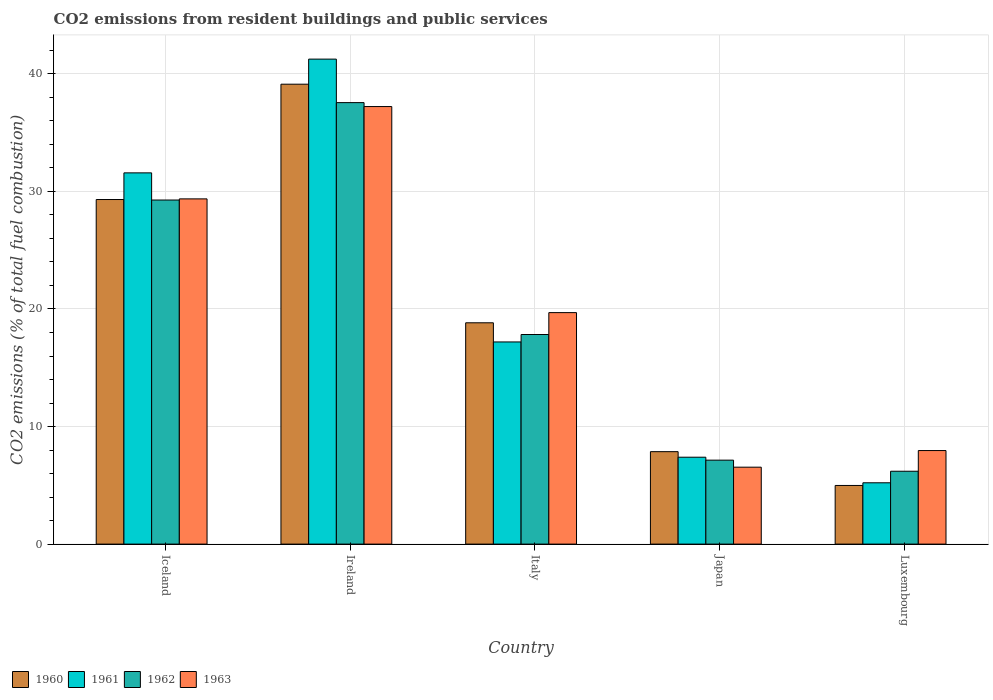How many different coloured bars are there?
Offer a terse response. 4. Are the number of bars per tick equal to the number of legend labels?
Ensure brevity in your answer.  Yes. Are the number of bars on each tick of the X-axis equal?
Offer a very short reply. Yes. How many bars are there on the 2nd tick from the right?
Provide a short and direct response. 4. What is the label of the 5th group of bars from the left?
Give a very brief answer. Luxembourg. In how many cases, is the number of bars for a given country not equal to the number of legend labels?
Offer a very short reply. 0. What is the total CO2 emitted in 1960 in Japan?
Ensure brevity in your answer.  7.86. Across all countries, what is the maximum total CO2 emitted in 1963?
Your response must be concise. 37.22. Across all countries, what is the minimum total CO2 emitted in 1962?
Offer a terse response. 6.2. In which country was the total CO2 emitted in 1962 maximum?
Offer a terse response. Ireland. In which country was the total CO2 emitted in 1962 minimum?
Ensure brevity in your answer.  Luxembourg. What is the total total CO2 emitted in 1961 in the graph?
Your answer should be very brief. 102.63. What is the difference between the total CO2 emitted in 1960 in Japan and that in Luxembourg?
Provide a succinct answer. 2.87. What is the difference between the total CO2 emitted in 1963 in Iceland and the total CO2 emitted in 1961 in Italy?
Keep it short and to the point. 12.17. What is the average total CO2 emitted in 1961 per country?
Keep it short and to the point. 20.53. What is the difference between the total CO2 emitted of/in 1960 and total CO2 emitted of/in 1961 in Luxembourg?
Your answer should be very brief. -0.23. What is the ratio of the total CO2 emitted in 1963 in Iceland to that in Italy?
Keep it short and to the point. 1.49. Is the total CO2 emitted in 1960 in Japan less than that in Luxembourg?
Provide a short and direct response. No. What is the difference between the highest and the second highest total CO2 emitted in 1962?
Ensure brevity in your answer.  -11.44. What is the difference between the highest and the lowest total CO2 emitted in 1961?
Your answer should be compact. 36.04. In how many countries, is the total CO2 emitted in 1963 greater than the average total CO2 emitted in 1963 taken over all countries?
Provide a succinct answer. 2. Is it the case that in every country, the sum of the total CO2 emitted in 1961 and total CO2 emitted in 1963 is greater than the sum of total CO2 emitted in 1962 and total CO2 emitted in 1960?
Keep it short and to the point. No. Are all the bars in the graph horizontal?
Provide a succinct answer. No. Are the values on the major ticks of Y-axis written in scientific E-notation?
Offer a terse response. No. Does the graph contain any zero values?
Your answer should be compact. No. Does the graph contain grids?
Give a very brief answer. Yes. How many legend labels are there?
Your response must be concise. 4. What is the title of the graph?
Provide a short and direct response. CO2 emissions from resident buildings and public services. Does "1971" appear as one of the legend labels in the graph?
Give a very brief answer. No. What is the label or title of the Y-axis?
Provide a succinct answer. CO2 emissions (% of total fuel combustion). What is the CO2 emissions (% of total fuel combustion) in 1960 in Iceland?
Offer a terse response. 29.31. What is the CO2 emissions (% of total fuel combustion) of 1961 in Iceland?
Offer a terse response. 31.58. What is the CO2 emissions (% of total fuel combustion) in 1962 in Iceland?
Offer a very short reply. 29.27. What is the CO2 emissions (% of total fuel combustion) in 1963 in Iceland?
Give a very brief answer. 29.37. What is the CO2 emissions (% of total fuel combustion) of 1960 in Ireland?
Offer a very short reply. 39.12. What is the CO2 emissions (% of total fuel combustion) of 1961 in Ireland?
Make the answer very short. 41.25. What is the CO2 emissions (% of total fuel combustion) of 1962 in Ireland?
Offer a terse response. 37.55. What is the CO2 emissions (% of total fuel combustion) in 1963 in Ireland?
Keep it short and to the point. 37.22. What is the CO2 emissions (% of total fuel combustion) of 1960 in Italy?
Offer a very short reply. 18.83. What is the CO2 emissions (% of total fuel combustion) of 1961 in Italy?
Your response must be concise. 17.2. What is the CO2 emissions (% of total fuel combustion) in 1962 in Italy?
Your response must be concise. 17.83. What is the CO2 emissions (% of total fuel combustion) of 1963 in Italy?
Ensure brevity in your answer.  19.69. What is the CO2 emissions (% of total fuel combustion) in 1960 in Japan?
Give a very brief answer. 7.86. What is the CO2 emissions (% of total fuel combustion) of 1961 in Japan?
Provide a succinct answer. 7.39. What is the CO2 emissions (% of total fuel combustion) of 1962 in Japan?
Your answer should be compact. 7.14. What is the CO2 emissions (% of total fuel combustion) of 1963 in Japan?
Provide a succinct answer. 6.54. What is the CO2 emissions (% of total fuel combustion) in 1960 in Luxembourg?
Provide a short and direct response. 4.99. What is the CO2 emissions (% of total fuel combustion) of 1961 in Luxembourg?
Your answer should be very brief. 5.21. What is the CO2 emissions (% of total fuel combustion) in 1962 in Luxembourg?
Your answer should be very brief. 6.2. What is the CO2 emissions (% of total fuel combustion) of 1963 in Luxembourg?
Keep it short and to the point. 7.96. Across all countries, what is the maximum CO2 emissions (% of total fuel combustion) of 1960?
Provide a succinct answer. 39.12. Across all countries, what is the maximum CO2 emissions (% of total fuel combustion) of 1961?
Give a very brief answer. 41.25. Across all countries, what is the maximum CO2 emissions (% of total fuel combustion) in 1962?
Your answer should be compact. 37.55. Across all countries, what is the maximum CO2 emissions (% of total fuel combustion) of 1963?
Give a very brief answer. 37.22. Across all countries, what is the minimum CO2 emissions (% of total fuel combustion) in 1960?
Make the answer very short. 4.99. Across all countries, what is the minimum CO2 emissions (% of total fuel combustion) of 1961?
Offer a terse response. 5.21. Across all countries, what is the minimum CO2 emissions (% of total fuel combustion) of 1962?
Make the answer very short. 6.2. Across all countries, what is the minimum CO2 emissions (% of total fuel combustion) in 1963?
Offer a terse response. 6.54. What is the total CO2 emissions (% of total fuel combustion) of 1960 in the graph?
Your response must be concise. 100.11. What is the total CO2 emissions (% of total fuel combustion) in 1961 in the graph?
Keep it short and to the point. 102.63. What is the total CO2 emissions (% of total fuel combustion) of 1962 in the graph?
Give a very brief answer. 97.99. What is the total CO2 emissions (% of total fuel combustion) of 1963 in the graph?
Provide a succinct answer. 100.78. What is the difference between the CO2 emissions (% of total fuel combustion) of 1960 in Iceland and that in Ireland?
Your response must be concise. -9.81. What is the difference between the CO2 emissions (% of total fuel combustion) of 1961 in Iceland and that in Ireland?
Offer a very short reply. -9.67. What is the difference between the CO2 emissions (% of total fuel combustion) in 1962 in Iceland and that in Ireland?
Offer a terse response. -8.29. What is the difference between the CO2 emissions (% of total fuel combustion) of 1963 in Iceland and that in Ireland?
Your answer should be compact. -7.85. What is the difference between the CO2 emissions (% of total fuel combustion) in 1960 in Iceland and that in Italy?
Your answer should be compact. 10.48. What is the difference between the CO2 emissions (% of total fuel combustion) of 1961 in Iceland and that in Italy?
Ensure brevity in your answer.  14.38. What is the difference between the CO2 emissions (% of total fuel combustion) in 1962 in Iceland and that in Italy?
Offer a terse response. 11.44. What is the difference between the CO2 emissions (% of total fuel combustion) of 1963 in Iceland and that in Italy?
Your answer should be compact. 9.67. What is the difference between the CO2 emissions (% of total fuel combustion) in 1960 in Iceland and that in Japan?
Your answer should be compact. 21.45. What is the difference between the CO2 emissions (% of total fuel combustion) of 1961 in Iceland and that in Japan?
Provide a succinct answer. 24.19. What is the difference between the CO2 emissions (% of total fuel combustion) in 1962 in Iceland and that in Japan?
Offer a very short reply. 22.13. What is the difference between the CO2 emissions (% of total fuel combustion) in 1963 in Iceland and that in Japan?
Give a very brief answer. 22.82. What is the difference between the CO2 emissions (% of total fuel combustion) of 1960 in Iceland and that in Luxembourg?
Make the answer very short. 24.32. What is the difference between the CO2 emissions (% of total fuel combustion) of 1961 in Iceland and that in Luxembourg?
Your response must be concise. 26.36. What is the difference between the CO2 emissions (% of total fuel combustion) of 1962 in Iceland and that in Luxembourg?
Your answer should be very brief. 23.07. What is the difference between the CO2 emissions (% of total fuel combustion) of 1963 in Iceland and that in Luxembourg?
Your answer should be compact. 21.41. What is the difference between the CO2 emissions (% of total fuel combustion) in 1960 in Ireland and that in Italy?
Provide a succinct answer. 20.29. What is the difference between the CO2 emissions (% of total fuel combustion) of 1961 in Ireland and that in Italy?
Your answer should be compact. 24.06. What is the difference between the CO2 emissions (% of total fuel combustion) of 1962 in Ireland and that in Italy?
Provide a short and direct response. 19.73. What is the difference between the CO2 emissions (% of total fuel combustion) of 1963 in Ireland and that in Italy?
Give a very brief answer. 17.53. What is the difference between the CO2 emissions (% of total fuel combustion) of 1960 in Ireland and that in Japan?
Provide a short and direct response. 31.26. What is the difference between the CO2 emissions (% of total fuel combustion) in 1961 in Ireland and that in Japan?
Provide a short and direct response. 33.86. What is the difference between the CO2 emissions (% of total fuel combustion) of 1962 in Ireland and that in Japan?
Offer a very short reply. 30.41. What is the difference between the CO2 emissions (% of total fuel combustion) of 1963 in Ireland and that in Japan?
Provide a succinct answer. 30.68. What is the difference between the CO2 emissions (% of total fuel combustion) of 1960 in Ireland and that in Luxembourg?
Make the answer very short. 34.13. What is the difference between the CO2 emissions (% of total fuel combustion) in 1961 in Ireland and that in Luxembourg?
Offer a terse response. 36.04. What is the difference between the CO2 emissions (% of total fuel combustion) of 1962 in Ireland and that in Luxembourg?
Make the answer very short. 31.36. What is the difference between the CO2 emissions (% of total fuel combustion) in 1963 in Ireland and that in Luxembourg?
Your response must be concise. 29.26. What is the difference between the CO2 emissions (% of total fuel combustion) in 1960 in Italy and that in Japan?
Offer a very short reply. 10.96. What is the difference between the CO2 emissions (% of total fuel combustion) in 1961 in Italy and that in Japan?
Give a very brief answer. 9.81. What is the difference between the CO2 emissions (% of total fuel combustion) of 1962 in Italy and that in Japan?
Give a very brief answer. 10.69. What is the difference between the CO2 emissions (% of total fuel combustion) in 1963 in Italy and that in Japan?
Ensure brevity in your answer.  13.15. What is the difference between the CO2 emissions (% of total fuel combustion) in 1960 in Italy and that in Luxembourg?
Keep it short and to the point. 13.84. What is the difference between the CO2 emissions (% of total fuel combustion) in 1961 in Italy and that in Luxembourg?
Make the answer very short. 11.98. What is the difference between the CO2 emissions (% of total fuel combustion) of 1962 in Italy and that in Luxembourg?
Offer a very short reply. 11.63. What is the difference between the CO2 emissions (% of total fuel combustion) of 1963 in Italy and that in Luxembourg?
Keep it short and to the point. 11.73. What is the difference between the CO2 emissions (% of total fuel combustion) in 1960 in Japan and that in Luxembourg?
Provide a succinct answer. 2.87. What is the difference between the CO2 emissions (% of total fuel combustion) of 1961 in Japan and that in Luxembourg?
Make the answer very short. 2.18. What is the difference between the CO2 emissions (% of total fuel combustion) in 1962 in Japan and that in Luxembourg?
Provide a succinct answer. 0.94. What is the difference between the CO2 emissions (% of total fuel combustion) in 1963 in Japan and that in Luxembourg?
Offer a terse response. -1.41. What is the difference between the CO2 emissions (% of total fuel combustion) in 1960 in Iceland and the CO2 emissions (% of total fuel combustion) in 1961 in Ireland?
Provide a short and direct response. -11.94. What is the difference between the CO2 emissions (% of total fuel combustion) of 1960 in Iceland and the CO2 emissions (% of total fuel combustion) of 1962 in Ireland?
Give a very brief answer. -8.24. What is the difference between the CO2 emissions (% of total fuel combustion) of 1960 in Iceland and the CO2 emissions (% of total fuel combustion) of 1963 in Ireland?
Give a very brief answer. -7.91. What is the difference between the CO2 emissions (% of total fuel combustion) of 1961 in Iceland and the CO2 emissions (% of total fuel combustion) of 1962 in Ireland?
Keep it short and to the point. -5.98. What is the difference between the CO2 emissions (% of total fuel combustion) in 1961 in Iceland and the CO2 emissions (% of total fuel combustion) in 1963 in Ireland?
Your response must be concise. -5.64. What is the difference between the CO2 emissions (% of total fuel combustion) of 1962 in Iceland and the CO2 emissions (% of total fuel combustion) of 1963 in Ireland?
Offer a very short reply. -7.95. What is the difference between the CO2 emissions (% of total fuel combustion) of 1960 in Iceland and the CO2 emissions (% of total fuel combustion) of 1961 in Italy?
Make the answer very short. 12.11. What is the difference between the CO2 emissions (% of total fuel combustion) in 1960 in Iceland and the CO2 emissions (% of total fuel combustion) in 1962 in Italy?
Make the answer very short. 11.48. What is the difference between the CO2 emissions (% of total fuel combustion) in 1960 in Iceland and the CO2 emissions (% of total fuel combustion) in 1963 in Italy?
Keep it short and to the point. 9.62. What is the difference between the CO2 emissions (% of total fuel combustion) in 1961 in Iceland and the CO2 emissions (% of total fuel combustion) in 1962 in Italy?
Provide a short and direct response. 13.75. What is the difference between the CO2 emissions (% of total fuel combustion) in 1961 in Iceland and the CO2 emissions (% of total fuel combustion) in 1963 in Italy?
Offer a terse response. 11.89. What is the difference between the CO2 emissions (% of total fuel combustion) in 1962 in Iceland and the CO2 emissions (% of total fuel combustion) in 1963 in Italy?
Make the answer very short. 9.58. What is the difference between the CO2 emissions (% of total fuel combustion) in 1960 in Iceland and the CO2 emissions (% of total fuel combustion) in 1961 in Japan?
Provide a succinct answer. 21.92. What is the difference between the CO2 emissions (% of total fuel combustion) in 1960 in Iceland and the CO2 emissions (% of total fuel combustion) in 1962 in Japan?
Your answer should be compact. 22.17. What is the difference between the CO2 emissions (% of total fuel combustion) in 1960 in Iceland and the CO2 emissions (% of total fuel combustion) in 1963 in Japan?
Give a very brief answer. 22.77. What is the difference between the CO2 emissions (% of total fuel combustion) in 1961 in Iceland and the CO2 emissions (% of total fuel combustion) in 1962 in Japan?
Offer a very short reply. 24.44. What is the difference between the CO2 emissions (% of total fuel combustion) in 1961 in Iceland and the CO2 emissions (% of total fuel combustion) in 1963 in Japan?
Make the answer very short. 25.04. What is the difference between the CO2 emissions (% of total fuel combustion) in 1962 in Iceland and the CO2 emissions (% of total fuel combustion) in 1963 in Japan?
Offer a very short reply. 22.73. What is the difference between the CO2 emissions (% of total fuel combustion) of 1960 in Iceland and the CO2 emissions (% of total fuel combustion) of 1961 in Luxembourg?
Provide a succinct answer. 24.1. What is the difference between the CO2 emissions (% of total fuel combustion) in 1960 in Iceland and the CO2 emissions (% of total fuel combustion) in 1962 in Luxembourg?
Provide a short and direct response. 23.11. What is the difference between the CO2 emissions (% of total fuel combustion) of 1960 in Iceland and the CO2 emissions (% of total fuel combustion) of 1963 in Luxembourg?
Provide a short and direct response. 21.35. What is the difference between the CO2 emissions (% of total fuel combustion) of 1961 in Iceland and the CO2 emissions (% of total fuel combustion) of 1962 in Luxembourg?
Make the answer very short. 25.38. What is the difference between the CO2 emissions (% of total fuel combustion) of 1961 in Iceland and the CO2 emissions (% of total fuel combustion) of 1963 in Luxembourg?
Offer a very short reply. 23.62. What is the difference between the CO2 emissions (% of total fuel combustion) of 1962 in Iceland and the CO2 emissions (% of total fuel combustion) of 1963 in Luxembourg?
Make the answer very short. 21.31. What is the difference between the CO2 emissions (% of total fuel combustion) of 1960 in Ireland and the CO2 emissions (% of total fuel combustion) of 1961 in Italy?
Give a very brief answer. 21.92. What is the difference between the CO2 emissions (% of total fuel combustion) of 1960 in Ireland and the CO2 emissions (% of total fuel combustion) of 1962 in Italy?
Provide a succinct answer. 21.29. What is the difference between the CO2 emissions (% of total fuel combustion) in 1960 in Ireland and the CO2 emissions (% of total fuel combustion) in 1963 in Italy?
Provide a succinct answer. 19.43. What is the difference between the CO2 emissions (% of total fuel combustion) of 1961 in Ireland and the CO2 emissions (% of total fuel combustion) of 1962 in Italy?
Ensure brevity in your answer.  23.42. What is the difference between the CO2 emissions (% of total fuel combustion) in 1961 in Ireland and the CO2 emissions (% of total fuel combustion) in 1963 in Italy?
Offer a very short reply. 21.56. What is the difference between the CO2 emissions (% of total fuel combustion) of 1962 in Ireland and the CO2 emissions (% of total fuel combustion) of 1963 in Italy?
Your answer should be very brief. 17.86. What is the difference between the CO2 emissions (% of total fuel combustion) in 1960 in Ireland and the CO2 emissions (% of total fuel combustion) in 1961 in Japan?
Provide a succinct answer. 31.73. What is the difference between the CO2 emissions (% of total fuel combustion) in 1960 in Ireland and the CO2 emissions (% of total fuel combustion) in 1962 in Japan?
Offer a terse response. 31.98. What is the difference between the CO2 emissions (% of total fuel combustion) of 1960 in Ireland and the CO2 emissions (% of total fuel combustion) of 1963 in Japan?
Give a very brief answer. 32.58. What is the difference between the CO2 emissions (% of total fuel combustion) in 1961 in Ireland and the CO2 emissions (% of total fuel combustion) in 1962 in Japan?
Give a very brief answer. 34.11. What is the difference between the CO2 emissions (% of total fuel combustion) in 1961 in Ireland and the CO2 emissions (% of total fuel combustion) in 1963 in Japan?
Offer a very short reply. 34.71. What is the difference between the CO2 emissions (% of total fuel combustion) of 1962 in Ireland and the CO2 emissions (% of total fuel combustion) of 1963 in Japan?
Your answer should be compact. 31.01. What is the difference between the CO2 emissions (% of total fuel combustion) in 1960 in Ireland and the CO2 emissions (% of total fuel combustion) in 1961 in Luxembourg?
Offer a very short reply. 33.91. What is the difference between the CO2 emissions (% of total fuel combustion) in 1960 in Ireland and the CO2 emissions (% of total fuel combustion) in 1962 in Luxembourg?
Offer a very short reply. 32.92. What is the difference between the CO2 emissions (% of total fuel combustion) of 1960 in Ireland and the CO2 emissions (% of total fuel combustion) of 1963 in Luxembourg?
Provide a short and direct response. 31.16. What is the difference between the CO2 emissions (% of total fuel combustion) of 1961 in Ireland and the CO2 emissions (% of total fuel combustion) of 1962 in Luxembourg?
Your response must be concise. 35.06. What is the difference between the CO2 emissions (% of total fuel combustion) in 1961 in Ireland and the CO2 emissions (% of total fuel combustion) in 1963 in Luxembourg?
Provide a succinct answer. 33.3. What is the difference between the CO2 emissions (% of total fuel combustion) of 1962 in Ireland and the CO2 emissions (% of total fuel combustion) of 1963 in Luxembourg?
Your response must be concise. 29.6. What is the difference between the CO2 emissions (% of total fuel combustion) in 1960 in Italy and the CO2 emissions (% of total fuel combustion) in 1961 in Japan?
Your answer should be compact. 11.43. What is the difference between the CO2 emissions (% of total fuel combustion) in 1960 in Italy and the CO2 emissions (% of total fuel combustion) in 1962 in Japan?
Provide a short and direct response. 11.68. What is the difference between the CO2 emissions (% of total fuel combustion) in 1960 in Italy and the CO2 emissions (% of total fuel combustion) in 1963 in Japan?
Your response must be concise. 12.28. What is the difference between the CO2 emissions (% of total fuel combustion) of 1961 in Italy and the CO2 emissions (% of total fuel combustion) of 1962 in Japan?
Your answer should be very brief. 10.05. What is the difference between the CO2 emissions (% of total fuel combustion) of 1961 in Italy and the CO2 emissions (% of total fuel combustion) of 1963 in Japan?
Provide a short and direct response. 10.65. What is the difference between the CO2 emissions (% of total fuel combustion) of 1962 in Italy and the CO2 emissions (% of total fuel combustion) of 1963 in Japan?
Offer a very short reply. 11.29. What is the difference between the CO2 emissions (% of total fuel combustion) in 1960 in Italy and the CO2 emissions (% of total fuel combustion) in 1961 in Luxembourg?
Your response must be concise. 13.61. What is the difference between the CO2 emissions (% of total fuel combustion) in 1960 in Italy and the CO2 emissions (% of total fuel combustion) in 1962 in Luxembourg?
Your answer should be compact. 12.63. What is the difference between the CO2 emissions (% of total fuel combustion) of 1960 in Italy and the CO2 emissions (% of total fuel combustion) of 1963 in Luxembourg?
Provide a short and direct response. 10.87. What is the difference between the CO2 emissions (% of total fuel combustion) in 1961 in Italy and the CO2 emissions (% of total fuel combustion) in 1962 in Luxembourg?
Offer a terse response. 11. What is the difference between the CO2 emissions (% of total fuel combustion) of 1961 in Italy and the CO2 emissions (% of total fuel combustion) of 1963 in Luxembourg?
Ensure brevity in your answer.  9.24. What is the difference between the CO2 emissions (% of total fuel combustion) in 1962 in Italy and the CO2 emissions (% of total fuel combustion) in 1963 in Luxembourg?
Make the answer very short. 9.87. What is the difference between the CO2 emissions (% of total fuel combustion) in 1960 in Japan and the CO2 emissions (% of total fuel combustion) in 1961 in Luxembourg?
Ensure brevity in your answer.  2.65. What is the difference between the CO2 emissions (% of total fuel combustion) of 1960 in Japan and the CO2 emissions (% of total fuel combustion) of 1962 in Luxembourg?
Offer a very short reply. 1.66. What is the difference between the CO2 emissions (% of total fuel combustion) in 1960 in Japan and the CO2 emissions (% of total fuel combustion) in 1963 in Luxembourg?
Offer a terse response. -0.09. What is the difference between the CO2 emissions (% of total fuel combustion) in 1961 in Japan and the CO2 emissions (% of total fuel combustion) in 1962 in Luxembourg?
Provide a succinct answer. 1.19. What is the difference between the CO2 emissions (% of total fuel combustion) in 1961 in Japan and the CO2 emissions (% of total fuel combustion) in 1963 in Luxembourg?
Provide a succinct answer. -0.57. What is the difference between the CO2 emissions (% of total fuel combustion) of 1962 in Japan and the CO2 emissions (% of total fuel combustion) of 1963 in Luxembourg?
Ensure brevity in your answer.  -0.82. What is the average CO2 emissions (% of total fuel combustion) of 1960 per country?
Your answer should be compact. 20.02. What is the average CO2 emissions (% of total fuel combustion) in 1961 per country?
Keep it short and to the point. 20.53. What is the average CO2 emissions (% of total fuel combustion) of 1962 per country?
Keep it short and to the point. 19.6. What is the average CO2 emissions (% of total fuel combustion) in 1963 per country?
Provide a short and direct response. 20.16. What is the difference between the CO2 emissions (% of total fuel combustion) in 1960 and CO2 emissions (% of total fuel combustion) in 1961 in Iceland?
Keep it short and to the point. -2.27. What is the difference between the CO2 emissions (% of total fuel combustion) in 1960 and CO2 emissions (% of total fuel combustion) in 1962 in Iceland?
Provide a succinct answer. 0.04. What is the difference between the CO2 emissions (% of total fuel combustion) of 1960 and CO2 emissions (% of total fuel combustion) of 1963 in Iceland?
Make the answer very short. -0.05. What is the difference between the CO2 emissions (% of total fuel combustion) in 1961 and CO2 emissions (% of total fuel combustion) in 1962 in Iceland?
Provide a succinct answer. 2.31. What is the difference between the CO2 emissions (% of total fuel combustion) of 1961 and CO2 emissions (% of total fuel combustion) of 1963 in Iceland?
Your answer should be very brief. 2.21. What is the difference between the CO2 emissions (% of total fuel combustion) of 1962 and CO2 emissions (% of total fuel combustion) of 1963 in Iceland?
Offer a terse response. -0.1. What is the difference between the CO2 emissions (% of total fuel combustion) of 1960 and CO2 emissions (% of total fuel combustion) of 1961 in Ireland?
Ensure brevity in your answer.  -2.13. What is the difference between the CO2 emissions (% of total fuel combustion) of 1960 and CO2 emissions (% of total fuel combustion) of 1962 in Ireland?
Your answer should be very brief. 1.57. What is the difference between the CO2 emissions (% of total fuel combustion) in 1960 and CO2 emissions (% of total fuel combustion) in 1963 in Ireland?
Your response must be concise. 1.9. What is the difference between the CO2 emissions (% of total fuel combustion) in 1961 and CO2 emissions (% of total fuel combustion) in 1962 in Ireland?
Provide a succinct answer. 3.7. What is the difference between the CO2 emissions (% of total fuel combustion) in 1961 and CO2 emissions (% of total fuel combustion) in 1963 in Ireland?
Ensure brevity in your answer.  4.03. What is the difference between the CO2 emissions (% of total fuel combustion) of 1962 and CO2 emissions (% of total fuel combustion) of 1963 in Ireland?
Provide a short and direct response. 0.34. What is the difference between the CO2 emissions (% of total fuel combustion) in 1960 and CO2 emissions (% of total fuel combustion) in 1961 in Italy?
Provide a succinct answer. 1.63. What is the difference between the CO2 emissions (% of total fuel combustion) in 1960 and CO2 emissions (% of total fuel combustion) in 1963 in Italy?
Provide a succinct answer. -0.87. What is the difference between the CO2 emissions (% of total fuel combustion) of 1961 and CO2 emissions (% of total fuel combustion) of 1962 in Italy?
Offer a very short reply. -0.63. What is the difference between the CO2 emissions (% of total fuel combustion) in 1961 and CO2 emissions (% of total fuel combustion) in 1963 in Italy?
Make the answer very short. -2.49. What is the difference between the CO2 emissions (% of total fuel combustion) in 1962 and CO2 emissions (% of total fuel combustion) in 1963 in Italy?
Make the answer very short. -1.86. What is the difference between the CO2 emissions (% of total fuel combustion) in 1960 and CO2 emissions (% of total fuel combustion) in 1961 in Japan?
Your answer should be very brief. 0.47. What is the difference between the CO2 emissions (% of total fuel combustion) of 1960 and CO2 emissions (% of total fuel combustion) of 1962 in Japan?
Offer a terse response. 0.72. What is the difference between the CO2 emissions (% of total fuel combustion) in 1960 and CO2 emissions (% of total fuel combustion) in 1963 in Japan?
Provide a short and direct response. 1.32. What is the difference between the CO2 emissions (% of total fuel combustion) in 1961 and CO2 emissions (% of total fuel combustion) in 1962 in Japan?
Offer a terse response. 0.25. What is the difference between the CO2 emissions (% of total fuel combustion) in 1961 and CO2 emissions (% of total fuel combustion) in 1963 in Japan?
Keep it short and to the point. 0.85. What is the difference between the CO2 emissions (% of total fuel combustion) in 1962 and CO2 emissions (% of total fuel combustion) in 1963 in Japan?
Your answer should be very brief. 0.6. What is the difference between the CO2 emissions (% of total fuel combustion) in 1960 and CO2 emissions (% of total fuel combustion) in 1961 in Luxembourg?
Ensure brevity in your answer.  -0.23. What is the difference between the CO2 emissions (% of total fuel combustion) in 1960 and CO2 emissions (% of total fuel combustion) in 1962 in Luxembourg?
Give a very brief answer. -1.21. What is the difference between the CO2 emissions (% of total fuel combustion) of 1960 and CO2 emissions (% of total fuel combustion) of 1963 in Luxembourg?
Your answer should be very brief. -2.97. What is the difference between the CO2 emissions (% of total fuel combustion) of 1961 and CO2 emissions (% of total fuel combustion) of 1962 in Luxembourg?
Make the answer very short. -0.98. What is the difference between the CO2 emissions (% of total fuel combustion) in 1961 and CO2 emissions (% of total fuel combustion) in 1963 in Luxembourg?
Ensure brevity in your answer.  -2.74. What is the difference between the CO2 emissions (% of total fuel combustion) of 1962 and CO2 emissions (% of total fuel combustion) of 1963 in Luxembourg?
Offer a very short reply. -1.76. What is the ratio of the CO2 emissions (% of total fuel combustion) of 1960 in Iceland to that in Ireland?
Your answer should be compact. 0.75. What is the ratio of the CO2 emissions (% of total fuel combustion) in 1961 in Iceland to that in Ireland?
Offer a very short reply. 0.77. What is the ratio of the CO2 emissions (% of total fuel combustion) of 1962 in Iceland to that in Ireland?
Provide a short and direct response. 0.78. What is the ratio of the CO2 emissions (% of total fuel combustion) of 1963 in Iceland to that in Ireland?
Your answer should be very brief. 0.79. What is the ratio of the CO2 emissions (% of total fuel combustion) of 1960 in Iceland to that in Italy?
Make the answer very short. 1.56. What is the ratio of the CO2 emissions (% of total fuel combustion) in 1961 in Iceland to that in Italy?
Give a very brief answer. 1.84. What is the ratio of the CO2 emissions (% of total fuel combustion) in 1962 in Iceland to that in Italy?
Your response must be concise. 1.64. What is the ratio of the CO2 emissions (% of total fuel combustion) in 1963 in Iceland to that in Italy?
Provide a succinct answer. 1.49. What is the ratio of the CO2 emissions (% of total fuel combustion) of 1960 in Iceland to that in Japan?
Provide a short and direct response. 3.73. What is the ratio of the CO2 emissions (% of total fuel combustion) in 1961 in Iceland to that in Japan?
Provide a short and direct response. 4.27. What is the ratio of the CO2 emissions (% of total fuel combustion) of 1962 in Iceland to that in Japan?
Ensure brevity in your answer.  4.1. What is the ratio of the CO2 emissions (% of total fuel combustion) of 1963 in Iceland to that in Japan?
Ensure brevity in your answer.  4.49. What is the ratio of the CO2 emissions (% of total fuel combustion) of 1960 in Iceland to that in Luxembourg?
Your answer should be compact. 5.88. What is the ratio of the CO2 emissions (% of total fuel combustion) in 1961 in Iceland to that in Luxembourg?
Provide a succinct answer. 6.06. What is the ratio of the CO2 emissions (% of total fuel combustion) of 1962 in Iceland to that in Luxembourg?
Offer a very short reply. 4.72. What is the ratio of the CO2 emissions (% of total fuel combustion) of 1963 in Iceland to that in Luxembourg?
Keep it short and to the point. 3.69. What is the ratio of the CO2 emissions (% of total fuel combustion) in 1960 in Ireland to that in Italy?
Your answer should be very brief. 2.08. What is the ratio of the CO2 emissions (% of total fuel combustion) of 1961 in Ireland to that in Italy?
Provide a short and direct response. 2.4. What is the ratio of the CO2 emissions (% of total fuel combustion) in 1962 in Ireland to that in Italy?
Your response must be concise. 2.11. What is the ratio of the CO2 emissions (% of total fuel combustion) in 1963 in Ireland to that in Italy?
Offer a terse response. 1.89. What is the ratio of the CO2 emissions (% of total fuel combustion) of 1960 in Ireland to that in Japan?
Keep it short and to the point. 4.98. What is the ratio of the CO2 emissions (% of total fuel combustion) of 1961 in Ireland to that in Japan?
Your response must be concise. 5.58. What is the ratio of the CO2 emissions (% of total fuel combustion) in 1962 in Ireland to that in Japan?
Provide a short and direct response. 5.26. What is the ratio of the CO2 emissions (% of total fuel combustion) of 1963 in Ireland to that in Japan?
Provide a succinct answer. 5.69. What is the ratio of the CO2 emissions (% of total fuel combustion) of 1960 in Ireland to that in Luxembourg?
Give a very brief answer. 7.84. What is the ratio of the CO2 emissions (% of total fuel combustion) in 1961 in Ireland to that in Luxembourg?
Keep it short and to the point. 7.91. What is the ratio of the CO2 emissions (% of total fuel combustion) in 1962 in Ireland to that in Luxembourg?
Ensure brevity in your answer.  6.06. What is the ratio of the CO2 emissions (% of total fuel combustion) of 1963 in Ireland to that in Luxembourg?
Your answer should be compact. 4.68. What is the ratio of the CO2 emissions (% of total fuel combustion) of 1960 in Italy to that in Japan?
Keep it short and to the point. 2.39. What is the ratio of the CO2 emissions (% of total fuel combustion) in 1961 in Italy to that in Japan?
Offer a very short reply. 2.33. What is the ratio of the CO2 emissions (% of total fuel combustion) in 1962 in Italy to that in Japan?
Your answer should be compact. 2.5. What is the ratio of the CO2 emissions (% of total fuel combustion) in 1963 in Italy to that in Japan?
Give a very brief answer. 3.01. What is the ratio of the CO2 emissions (% of total fuel combustion) of 1960 in Italy to that in Luxembourg?
Your answer should be compact. 3.77. What is the ratio of the CO2 emissions (% of total fuel combustion) in 1961 in Italy to that in Luxembourg?
Your answer should be compact. 3.3. What is the ratio of the CO2 emissions (% of total fuel combustion) in 1962 in Italy to that in Luxembourg?
Offer a very short reply. 2.88. What is the ratio of the CO2 emissions (% of total fuel combustion) of 1963 in Italy to that in Luxembourg?
Give a very brief answer. 2.47. What is the ratio of the CO2 emissions (% of total fuel combustion) of 1960 in Japan to that in Luxembourg?
Offer a very short reply. 1.58. What is the ratio of the CO2 emissions (% of total fuel combustion) of 1961 in Japan to that in Luxembourg?
Offer a terse response. 1.42. What is the ratio of the CO2 emissions (% of total fuel combustion) of 1962 in Japan to that in Luxembourg?
Give a very brief answer. 1.15. What is the ratio of the CO2 emissions (% of total fuel combustion) in 1963 in Japan to that in Luxembourg?
Provide a short and direct response. 0.82. What is the difference between the highest and the second highest CO2 emissions (% of total fuel combustion) of 1960?
Offer a very short reply. 9.81. What is the difference between the highest and the second highest CO2 emissions (% of total fuel combustion) in 1961?
Your answer should be compact. 9.67. What is the difference between the highest and the second highest CO2 emissions (% of total fuel combustion) of 1962?
Your answer should be compact. 8.29. What is the difference between the highest and the second highest CO2 emissions (% of total fuel combustion) in 1963?
Provide a short and direct response. 7.85. What is the difference between the highest and the lowest CO2 emissions (% of total fuel combustion) of 1960?
Your answer should be very brief. 34.13. What is the difference between the highest and the lowest CO2 emissions (% of total fuel combustion) of 1961?
Provide a succinct answer. 36.04. What is the difference between the highest and the lowest CO2 emissions (% of total fuel combustion) in 1962?
Provide a succinct answer. 31.36. What is the difference between the highest and the lowest CO2 emissions (% of total fuel combustion) of 1963?
Provide a succinct answer. 30.68. 